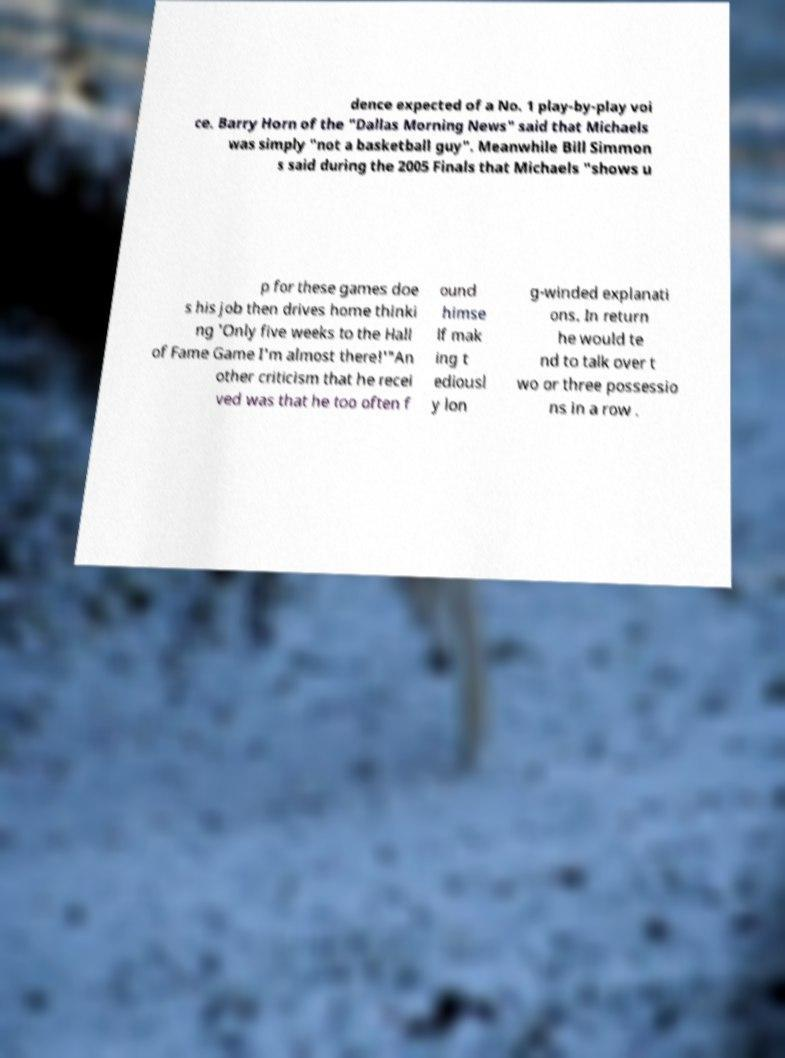For documentation purposes, I need the text within this image transcribed. Could you provide that? dence expected of a No. 1 play-by-play voi ce. Barry Horn of the "Dallas Morning News" said that Michaels was simply "not a basketball guy". Meanwhile Bill Simmon s said during the 2005 Finals that Michaels "shows u p for these games doe s his job then drives home thinki ng 'Only five weeks to the Hall of Fame Game I'm almost there!'"An other criticism that he recei ved was that he too often f ound himse lf mak ing t ediousl y lon g-winded explanati ons. In return he would te nd to talk over t wo or three possessio ns in a row . 